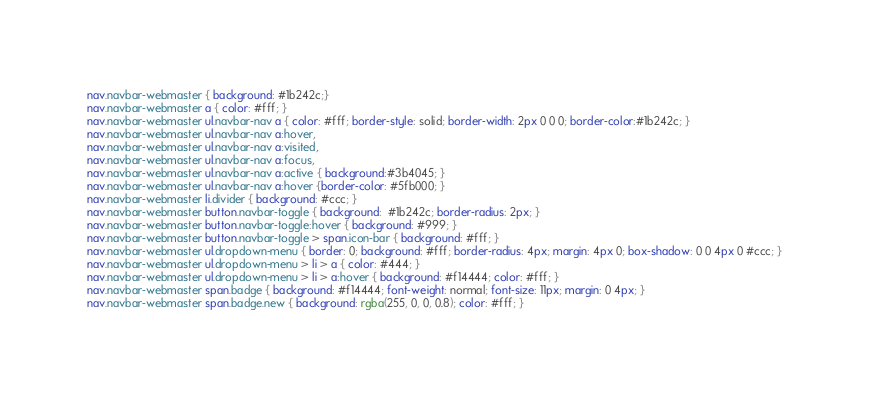Convert code to text. <code><loc_0><loc_0><loc_500><loc_500><_CSS_>nav.navbar-webmaster { background: #1b242c;}
nav.navbar-webmaster a { color: #fff; }
nav.navbar-webmaster ul.navbar-nav a { color: #fff; border-style: solid; border-width: 2px 0 0 0; border-color:#1b242c; }
nav.navbar-webmaster ul.navbar-nav a:hover,
nav.navbar-webmaster ul.navbar-nav a:visited,
nav.navbar-webmaster ul.navbar-nav a:focus,
nav.navbar-webmaster ul.navbar-nav a:active { background:#3b4045; }
nav.navbar-webmaster ul.navbar-nav a:hover {border-color: #5fb000; }
nav.navbar-webmaster li.divider { background: #ccc; }
nav.navbar-webmaster button.navbar-toggle { background:  #1b242c; border-radius: 2px; }
nav.navbar-webmaster button.navbar-toggle:hover { background: #999; }
nav.navbar-webmaster button.navbar-toggle > span.icon-bar { background: #fff; }
nav.navbar-webmaster ul.dropdown-menu { border: 0; background: #fff; border-radius: 4px; margin: 4px 0; box-shadow: 0 0 4px 0 #ccc; }
nav.navbar-webmaster ul.dropdown-menu > li > a { color: #444; }
nav.navbar-webmaster ul.dropdown-menu > li > a:hover { background: #f14444; color: #fff; }
nav.navbar-webmaster span.badge { background: #f14444; font-weight: normal; font-size: 11px; margin: 0 4px; }
nav.navbar-webmaster span.badge.new { background: rgba(255, 0, 0, 0.8); color: #fff; }</code> 